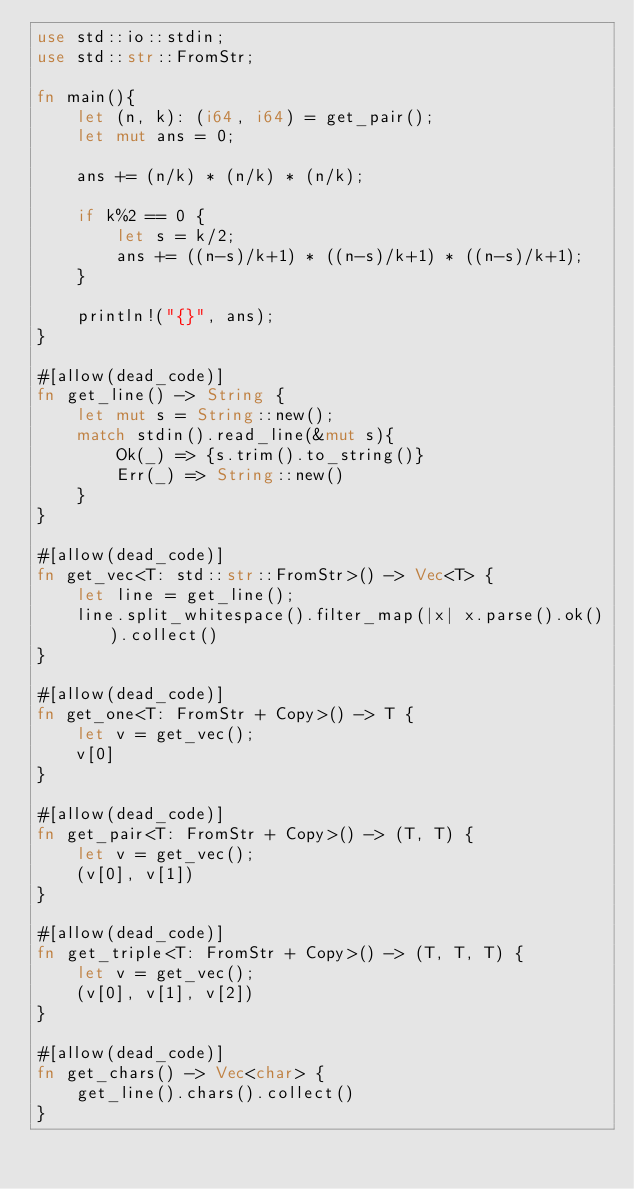Convert code to text. <code><loc_0><loc_0><loc_500><loc_500><_Rust_>use std::io::stdin;
use std::str::FromStr;

fn main(){
    let (n, k): (i64, i64) = get_pair();
    let mut ans = 0;

    ans += (n/k) * (n/k) * (n/k);

    if k%2 == 0 {
        let s = k/2;
        ans += ((n-s)/k+1) * ((n-s)/k+1) * ((n-s)/k+1);
    }

    println!("{}", ans);
}

#[allow(dead_code)]
fn get_line() -> String {
    let mut s = String::new();
    match stdin().read_line(&mut s){
        Ok(_) => {s.trim().to_string()}
        Err(_) => String::new()
    }
}

#[allow(dead_code)]
fn get_vec<T: std::str::FromStr>() -> Vec<T> {
    let line = get_line();
    line.split_whitespace().filter_map(|x| x.parse().ok()).collect()
}

#[allow(dead_code)]
fn get_one<T: FromStr + Copy>() -> T {
    let v = get_vec();
    v[0]
}

#[allow(dead_code)]
fn get_pair<T: FromStr + Copy>() -> (T, T) {
    let v = get_vec();
    (v[0], v[1])
}

#[allow(dead_code)]
fn get_triple<T: FromStr + Copy>() -> (T, T, T) {
    let v = get_vec();
    (v[0], v[1], v[2])
}

#[allow(dead_code)]
fn get_chars() -> Vec<char> {
    get_line().chars().collect()
}
</code> 